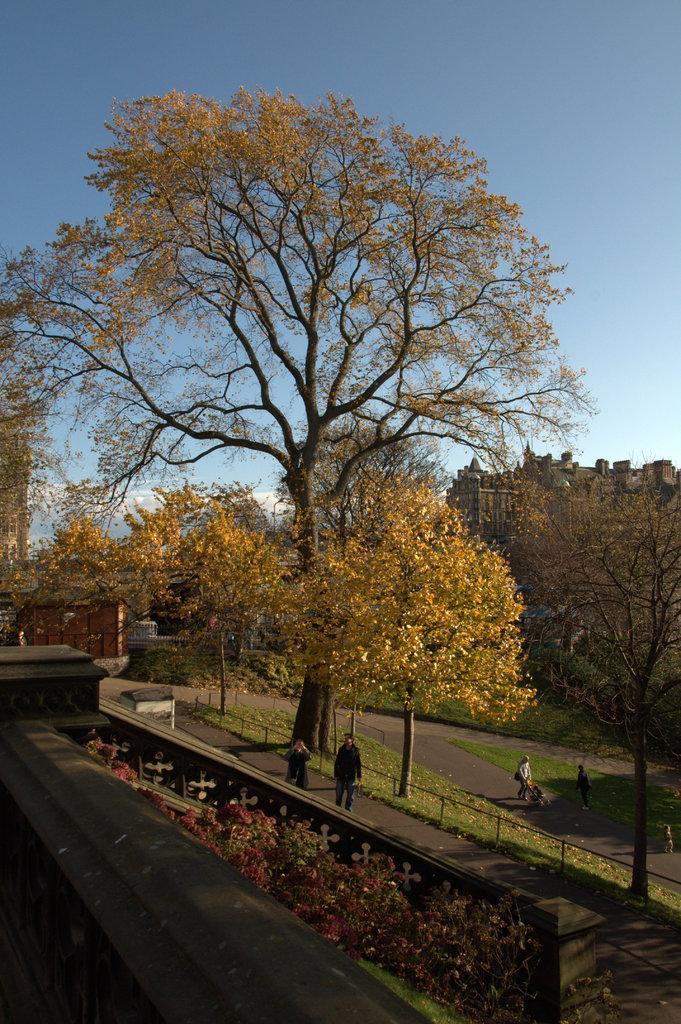In one or two sentences, can you explain what this image depicts? In the picture we can see a road and two persons are walking on it and besides and in the background, we can see some trees on the grass surface and behind it we can see some buildings and sky. 